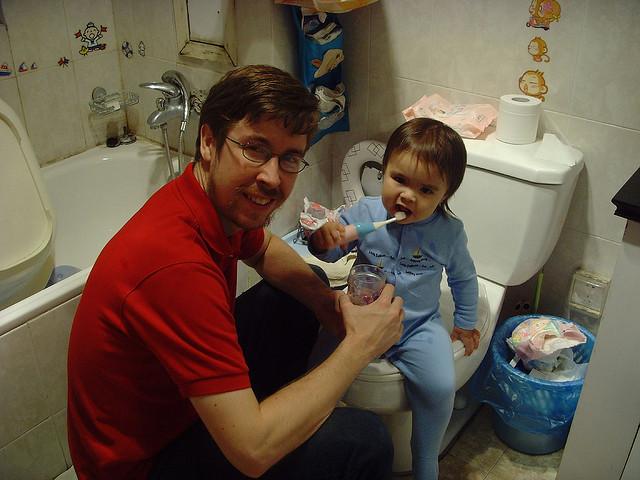Is this kid potty trained?
Give a very brief answer. No. What is the guy gripping?
Be succinct. Cup. Is that toothbrush electric?
Short answer required. Yes. Is the water running in the bathtub?
Concise answer only. No. What kind of shirt is the man wearing?
Concise answer only. Polo. What color is the toothbrush handle?
Write a very short answer. White. What is the man doing to the toilet?
Short answer required. Nothing. What animal is seen here?
Keep it brief. Human. What liquid is in the glass on the counter?
Keep it brief. Water. Is the man standing?
Write a very short answer. No. What is going on?
Keep it brief. Brushing teeth. What is the man looking at?
Keep it brief. Camera. What is the kneeling on?
Give a very brief answer. Floor. How many toothbrushes is this?
Concise answer only. 1. Is the man fixing the toilet?
Give a very brief answer. No. 